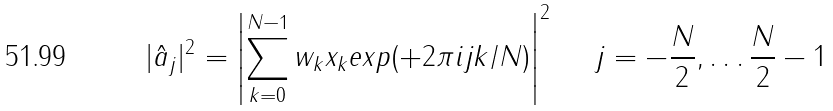<formula> <loc_0><loc_0><loc_500><loc_500>| \hat { a } _ { j } | ^ { 2 } = \left | \sum _ { k = 0 } ^ { N - 1 } w _ { k } x _ { k } e x p ( + 2 \pi i j k / N ) \right | ^ { 2 } \quad \ j = - \frac { N } { 2 } , \dots \frac { N } { 2 } - 1</formula> 